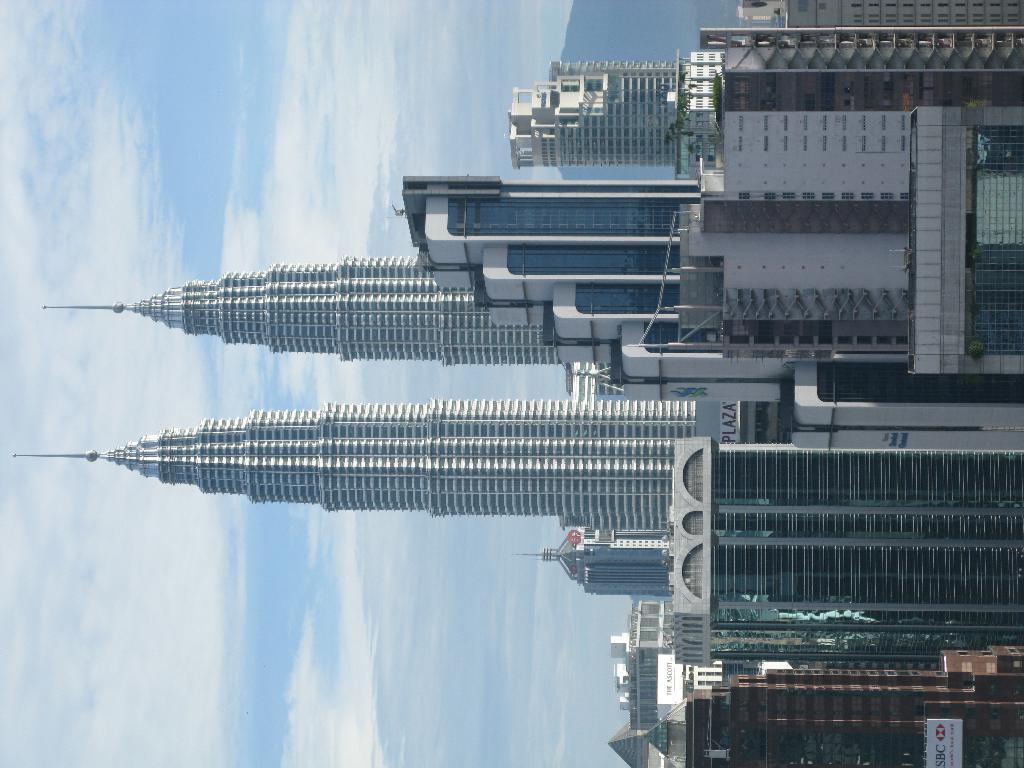What structures can be seen on the right side of the image? There are buildings and towers on the right side of the image. What is visible in the sky on the left side of the image? There are clouds in the sky on the left side of the image. What type of vest is being worn by the tail in the image? There is no vest or tail present in the image; it features buildings, towers, and clouds. 